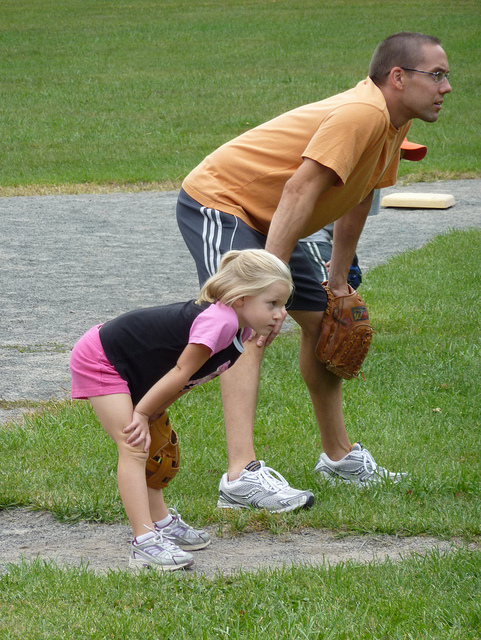What kind of location are they at? They seem to be in an open grassy area that could be a park or a backyard. There's no immediate evidence of urban structures, making it more likely to be a recreational or residential space. Is the weather suitable for outdoor activities? The weather seems mild and comfortable for outdoor activities, with ample daylight and no sign of rain. The attire of the individuals suggests it's neither too hot nor too cold. 